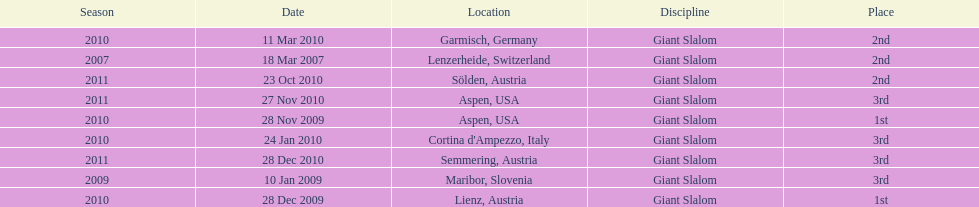What was the finishing place of the last race in december 2010? 3rd. 